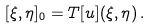Convert formula to latex. <formula><loc_0><loc_0><loc_500><loc_500>[ \xi , \eta ] _ { 0 } = T [ u ] ( \xi , \eta ) \, .</formula> 